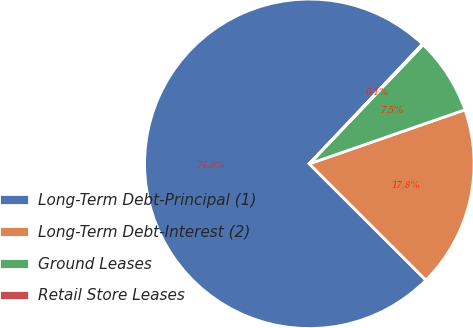Convert chart to OTSL. <chart><loc_0><loc_0><loc_500><loc_500><pie_chart><fcel>Long-Term Debt-Principal (1)<fcel>Long-Term Debt-Interest (2)<fcel>Ground Leases<fcel>Retail Store Leases<nl><fcel>74.56%<fcel>17.8%<fcel>7.54%<fcel>0.1%<nl></chart> 